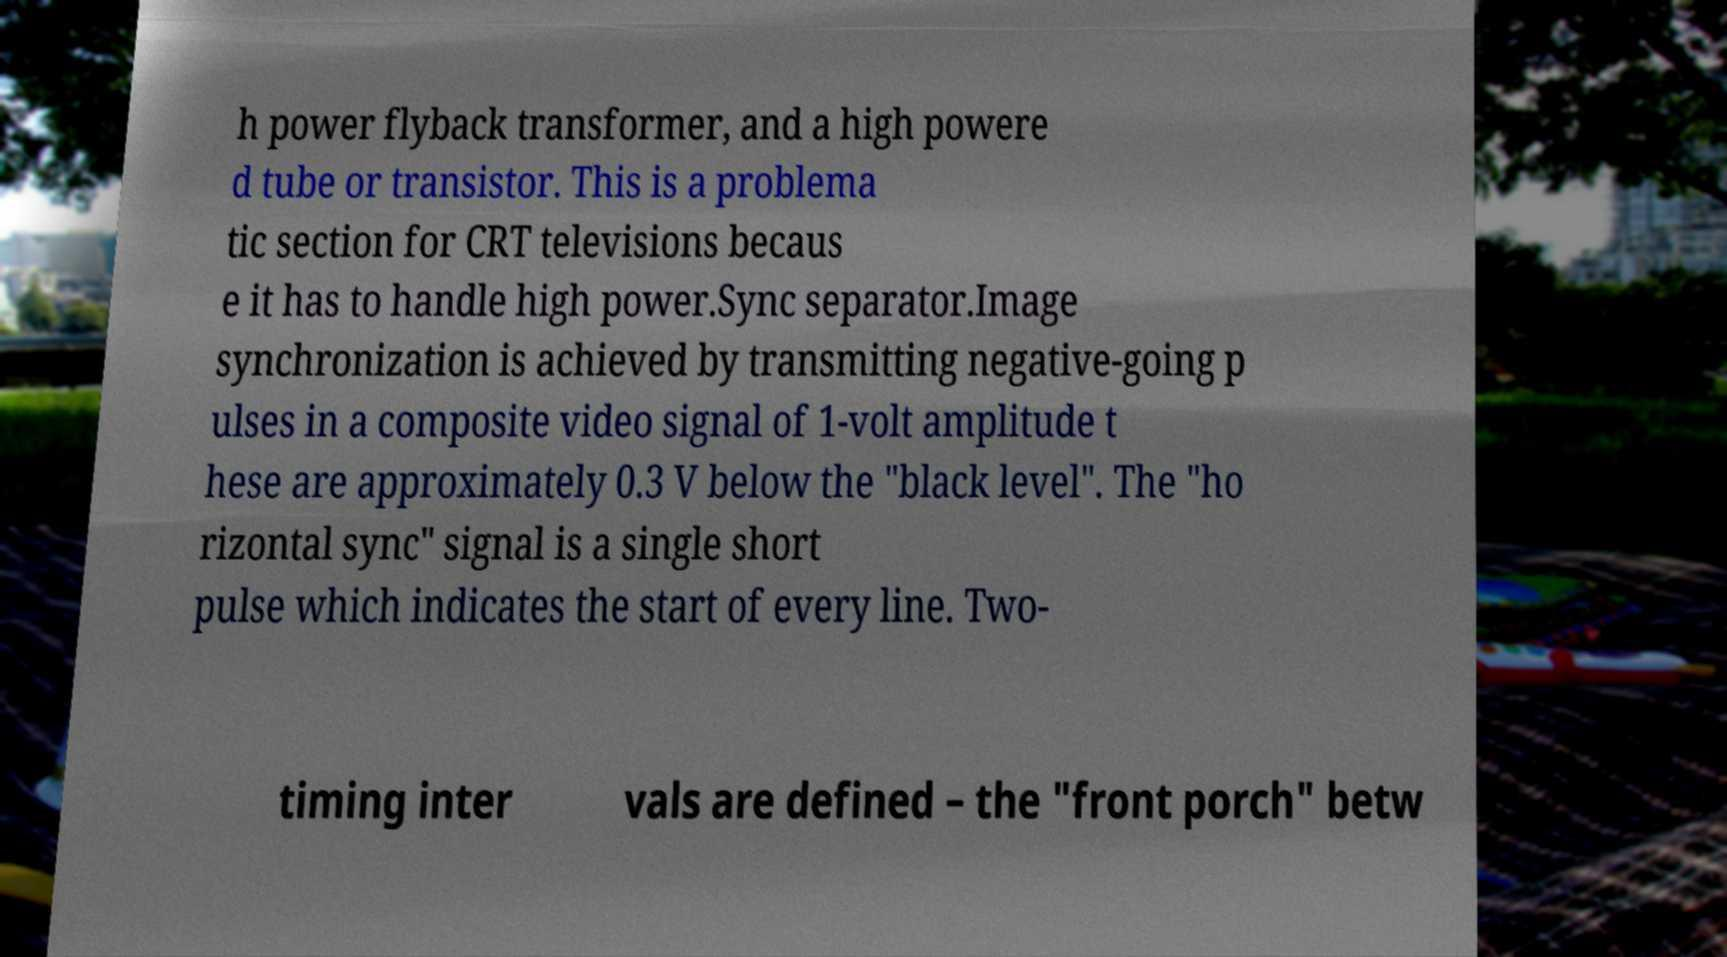Please read and relay the text visible in this image. What does it say? h power flyback transformer, and a high powere d tube or transistor. This is a problema tic section for CRT televisions becaus e it has to handle high power.Sync separator.Image synchronization is achieved by transmitting negative-going p ulses in a composite video signal of 1-volt amplitude t hese are approximately 0.3 V below the "black level". The "ho rizontal sync" signal is a single short pulse which indicates the start of every line. Two- timing inter vals are defined – the "front porch" betw 